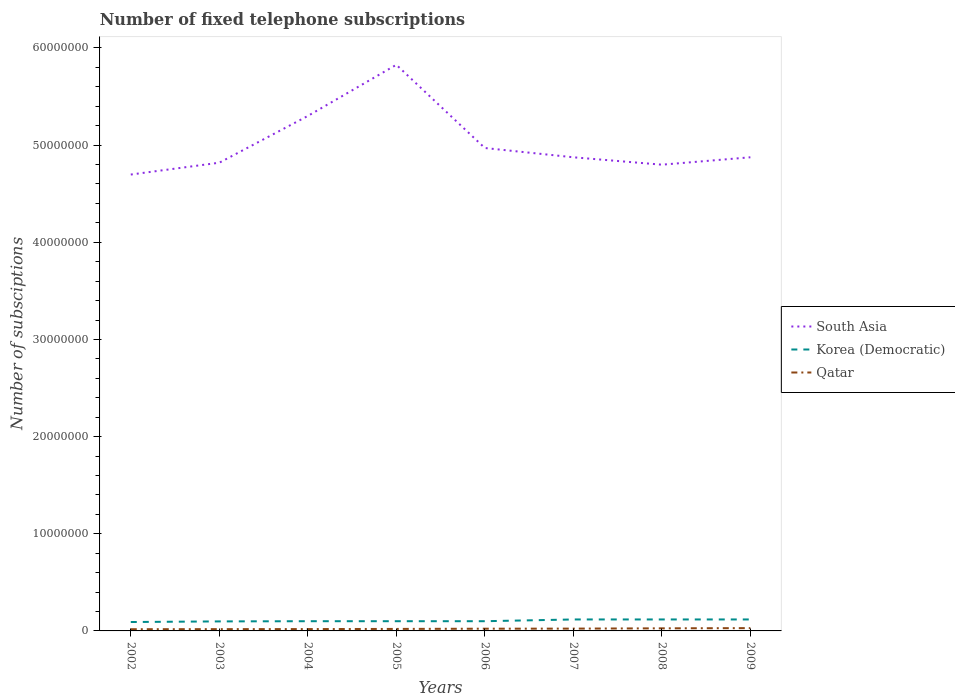Is the number of lines equal to the number of legend labels?
Offer a very short reply. Yes. Across all years, what is the maximum number of fixed telephone subscriptions in Qatar?
Ensure brevity in your answer.  1.77e+05. In which year was the number of fixed telephone subscriptions in South Asia maximum?
Give a very brief answer. 2002. What is the total number of fixed telephone subscriptions in Korea (Democratic) in the graph?
Offer a terse response. -1.80e+05. What is the difference between the highest and the second highest number of fixed telephone subscriptions in Qatar?
Make the answer very short. 1.11e+05. Is the number of fixed telephone subscriptions in South Asia strictly greater than the number of fixed telephone subscriptions in Korea (Democratic) over the years?
Your answer should be compact. No. Where does the legend appear in the graph?
Your answer should be compact. Center right. How many legend labels are there?
Make the answer very short. 3. What is the title of the graph?
Give a very brief answer. Number of fixed telephone subscriptions. What is the label or title of the X-axis?
Make the answer very short. Years. What is the label or title of the Y-axis?
Your answer should be very brief. Number of subsciptions. What is the Number of subsciptions of South Asia in 2002?
Offer a very short reply. 4.70e+07. What is the Number of subsciptions in Korea (Democratic) in 2002?
Provide a succinct answer. 9.16e+05. What is the Number of subsciptions of Qatar in 2002?
Your answer should be compact. 1.77e+05. What is the Number of subsciptions of South Asia in 2003?
Your response must be concise. 4.82e+07. What is the Number of subsciptions in Korea (Democratic) in 2003?
Keep it short and to the point. 9.80e+05. What is the Number of subsciptions in Qatar in 2003?
Provide a succinct answer. 1.85e+05. What is the Number of subsciptions in South Asia in 2004?
Provide a succinct answer. 5.30e+07. What is the Number of subsciptions of Korea (Democratic) in 2004?
Offer a very short reply. 1.00e+06. What is the Number of subsciptions in Qatar in 2004?
Provide a short and direct response. 1.91e+05. What is the Number of subsciptions of South Asia in 2005?
Keep it short and to the point. 5.83e+07. What is the Number of subsciptions of Qatar in 2005?
Keep it short and to the point. 2.05e+05. What is the Number of subsciptions of South Asia in 2006?
Make the answer very short. 4.97e+07. What is the Number of subsciptions in Qatar in 2006?
Provide a short and direct response. 2.28e+05. What is the Number of subsciptions in South Asia in 2007?
Provide a short and direct response. 4.87e+07. What is the Number of subsciptions in Korea (Democratic) in 2007?
Give a very brief answer. 1.18e+06. What is the Number of subsciptions of Qatar in 2007?
Provide a short and direct response. 2.37e+05. What is the Number of subsciptions of South Asia in 2008?
Your answer should be very brief. 4.80e+07. What is the Number of subsciptions of Korea (Democratic) in 2008?
Provide a short and direct response. 1.18e+06. What is the Number of subsciptions in Qatar in 2008?
Provide a succinct answer. 2.66e+05. What is the Number of subsciptions in South Asia in 2009?
Ensure brevity in your answer.  4.87e+07. What is the Number of subsciptions in Korea (Democratic) in 2009?
Make the answer very short. 1.18e+06. What is the Number of subsciptions of Qatar in 2009?
Your answer should be very brief. 2.88e+05. Across all years, what is the maximum Number of subsciptions of South Asia?
Your response must be concise. 5.83e+07. Across all years, what is the maximum Number of subsciptions of Korea (Democratic)?
Provide a succinct answer. 1.18e+06. Across all years, what is the maximum Number of subsciptions in Qatar?
Your answer should be compact. 2.88e+05. Across all years, what is the minimum Number of subsciptions in South Asia?
Keep it short and to the point. 4.70e+07. Across all years, what is the minimum Number of subsciptions of Korea (Democratic)?
Offer a terse response. 9.16e+05. Across all years, what is the minimum Number of subsciptions in Qatar?
Your answer should be compact. 1.77e+05. What is the total Number of subsciptions in South Asia in the graph?
Provide a succinct answer. 4.02e+08. What is the total Number of subsciptions of Korea (Democratic) in the graph?
Your answer should be very brief. 8.44e+06. What is the total Number of subsciptions in Qatar in the graph?
Provide a succinct answer. 1.78e+06. What is the difference between the Number of subsciptions in South Asia in 2002 and that in 2003?
Your answer should be compact. -1.22e+06. What is the difference between the Number of subsciptions in Korea (Democratic) in 2002 and that in 2003?
Your answer should be very brief. -6.40e+04. What is the difference between the Number of subsciptions in Qatar in 2002 and that in 2003?
Make the answer very short. -7989. What is the difference between the Number of subsciptions in South Asia in 2002 and that in 2004?
Provide a succinct answer. -6.03e+06. What is the difference between the Number of subsciptions in Korea (Democratic) in 2002 and that in 2004?
Your answer should be compact. -8.40e+04. What is the difference between the Number of subsciptions of Qatar in 2002 and that in 2004?
Provide a succinct answer. -1.44e+04. What is the difference between the Number of subsciptions of South Asia in 2002 and that in 2005?
Your response must be concise. -1.13e+07. What is the difference between the Number of subsciptions of Korea (Democratic) in 2002 and that in 2005?
Your answer should be compact. -8.40e+04. What is the difference between the Number of subsciptions in Qatar in 2002 and that in 2005?
Give a very brief answer. -2.89e+04. What is the difference between the Number of subsciptions in South Asia in 2002 and that in 2006?
Your answer should be very brief. -2.73e+06. What is the difference between the Number of subsciptions of Korea (Democratic) in 2002 and that in 2006?
Your response must be concise. -8.40e+04. What is the difference between the Number of subsciptions in Qatar in 2002 and that in 2006?
Make the answer very short. -5.18e+04. What is the difference between the Number of subsciptions in South Asia in 2002 and that in 2007?
Ensure brevity in your answer.  -1.78e+06. What is the difference between the Number of subsciptions of Korea (Democratic) in 2002 and that in 2007?
Your answer should be compact. -2.64e+05. What is the difference between the Number of subsciptions of Qatar in 2002 and that in 2007?
Provide a short and direct response. -6.08e+04. What is the difference between the Number of subsciptions of South Asia in 2002 and that in 2008?
Make the answer very short. -1.01e+06. What is the difference between the Number of subsciptions of Korea (Democratic) in 2002 and that in 2008?
Provide a succinct answer. -2.64e+05. What is the difference between the Number of subsciptions of Qatar in 2002 and that in 2008?
Offer a terse response. -8.93e+04. What is the difference between the Number of subsciptions in South Asia in 2002 and that in 2009?
Your response must be concise. -1.78e+06. What is the difference between the Number of subsciptions in Korea (Democratic) in 2002 and that in 2009?
Your answer should be compact. -2.64e+05. What is the difference between the Number of subsciptions in Qatar in 2002 and that in 2009?
Offer a very short reply. -1.11e+05. What is the difference between the Number of subsciptions of South Asia in 2003 and that in 2004?
Offer a terse response. -4.81e+06. What is the difference between the Number of subsciptions of Korea (Democratic) in 2003 and that in 2004?
Offer a very short reply. -2.00e+04. What is the difference between the Number of subsciptions of Qatar in 2003 and that in 2004?
Provide a short and direct response. -6368. What is the difference between the Number of subsciptions in South Asia in 2003 and that in 2005?
Ensure brevity in your answer.  -1.01e+07. What is the difference between the Number of subsciptions in Korea (Democratic) in 2003 and that in 2005?
Keep it short and to the point. -2.00e+04. What is the difference between the Number of subsciptions in Qatar in 2003 and that in 2005?
Ensure brevity in your answer.  -2.09e+04. What is the difference between the Number of subsciptions of South Asia in 2003 and that in 2006?
Provide a short and direct response. -1.51e+06. What is the difference between the Number of subsciptions in Qatar in 2003 and that in 2006?
Offer a terse response. -4.38e+04. What is the difference between the Number of subsciptions in South Asia in 2003 and that in 2007?
Your answer should be compact. -5.59e+05. What is the difference between the Number of subsciptions in Qatar in 2003 and that in 2007?
Keep it short and to the point. -5.29e+04. What is the difference between the Number of subsciptions in South Asia in 2003 and that in 2008?
Provide a short and direct response. 2.04e+05. What is the difference between the Number of subsciptions of Korea (Democratic) in 2003 and that in 2008?
Give a very brief answer. -2.00e+05. What is the difference between the Number of subsciptions of Qatar in 2003 and that in 2008?
Keep it short and to the point. -8.14e+04. What is the difference between the Number of subsciptions of South Asia in 2003 and that in 2009?
Your answer should be compact. -5.59e+05. What is the difference between the Number of subsciptions in Qatar in 2003 and that in 2009?
Give a very brief answer. -1.03e+05. What is the difference between the Number of subsciptions of South Asia in 2004 and that in 2005?
Your response must be concise. -5.27e+06. What is the difference between the Number of subsciptions in Qatar in 2004 and that in 2005?
Make the answer very short. -1.45e+04. What is the difference between the Number of subsciptions of South Asia in 2004 and that in 2006?
Provide a succinct answer. 3.30e+06. What is the difference between the Number of subsciptions of Qatar in 2004 and that in 2006?
Ensure brevity in your answer.  -3.75e+04. What is the difference between the Number of subsciptions of South Asia in 2004 and that in 2007?
Provide a succinct answer. 4.25e+06. What is the difference between the Number of subsciptions of Qatar in 2004 and that in 2007?
Make the answer very short. -4.65e+04. What is the difference between the Number of subsciptions of South Asia in 2004 and that in 2008?
Ensure brevity in your answer.  5.02e+06. What is the difference between the Number of subsciptions of Qatar in 2004 and that in 2008?
Ensure brevity in your answer.  -7.50e+04. What is the difference between the Number of subsciptions in South Asia in 2004 and that in 2009?
Your answer should be very brief. 4.25e+06. What is the difference between the Number of subsciptions in Qatar in 2004 and that in 2009?
Make the answer very short. -9.71e+04. What is the difference between the Number of subsciptions of South Asia in 2005 and that in 2006?
Offer a very short reply. 8.56e+06. What is the difference between the Number of subsciptions in Qatar in 2005 and that in 2006?
Your answer should be compact. -2.29e+04. What is the difference between the Number of subsciptions of South Asia in 2005 and that in 2007?
Provide a succinct answer. 9.52e+06. What is the difference between the Number of subsciptions in Korea (Democratic) in 2005 and that in 2007?
Provide a succinct answer. -1.80e+05. What is the difference between the Number of subsciptions of Qatar in 2005 and that in 2007?
Offer a terse response. -3.20e+04. What is the difference between the Number of subsciptions in South Asia in 2005 and that in 2008?
Offer a very short reply. 1.03e+07. What is the difference between the Number of subsciptions in Korea (Democratic) in 2005 and that in 2008?
Make the answer very short. -1.80e+05. What is the difference between the Number of subsciptions in Qatar in 2005 and that in 2008?
Offer a very short reply. -6.05e+04. What is the difference between the Number of subsciptions in South Asia in 2005 and that in 2009?
Keep it short and to the point. 9.52e+06. What is the difference between the Number of subsciptions of Qatar in 2005 and that in 2009?
Provide a short and direct response. -8.26e+04. What is the difference between the Number of subsciptions of South Asia in 2006 and that in 2007?
Ensure brevity in your answer.  9.54e+05. What is the difference between the Number of subsciptions of Korea (Democratic) in 2006 and that in 2007?
Your answer should be compact. -1.80e+05. What is the difference between the Number of subsciptions in Qatar in 2006 and that in 2007?
Give a very brief answer. -9041. What is the difference between the Number of subsciptions in South Asia in 2006 and that in 2008?
Keep it short and to the point. 1.72e+06. What is the difference between the Number of subsciptions in Korea (Democratic) in 2006 and that in 2008?
Your answer should be very brief. -1.80e+05. What is the difference between the Number of subsciptions of Qatar in 2006 and that in 2008?
Ensure brevity in your answer.  -3.75e+04. What is the difference between the Number of subsciptions in South Asia in 2006 and that in 2009?
Give a very brief answer. 9.54e+05. What is the difference between the Number of subsciptions of Korea (Democratic) in 2006 and that in 2009?
Your response must be concise. -1.80e+05. What is the difference between the Number of subsciptions in Qatar in 2006 and that in 2009?
Your answer should be compact. -5.96e+04. What is the difference between the Number of subsciptions of South Asia in 2007 and that in 2008?
Your answer should be compact. 7.62e+05. What is the difference between the Number of subsciptions in Qatar in 2007 and that in 2008?
Your answer should be compact. -2.85e+04. What is the difference between the Number of subsciptions of South Asia in 2007 and that in 2009?
Give a very brief answer. -456. What is the difference between the Number of subsciptions of Korea (Democratic) in 2007 and that in 2009?
Ensure brevity in your answer.  0. What is the difference between the Number of subsciptions in Qatar in 2007 and that in 2009?
Offer a very short reply. -5.06e+04. What is the difference between the Number of subsciptions in South Asia in 2008 and that in 2009?
Provide a succinct answer. -7.63e+05. What is the difference between the Number of subsciptions in Qatar in 2008 and that in 2009?
Make the answer very short. -2.21e+04. What is the difference between the Number of subsciptions in South Asia in 2002 and the Number of subsciptions in Korea (Democratic) in 2003?
Provide a succinct answer. 4.60e+07. What is the difference between the Number of subsciptions of South Asia in 2002 and the Number of subsciptions of Qatar in 2003?
Provide a short and direct response. 4.68e+07. What is the difference between the Number of subsciptions of Korea (Democratic) in 2002 and the Number of subsciptions of Qatar in 2003?
Offer a very short reply. 7.31e+05. What is the difference between the Number of subsciptions of South Asia in 2002 and the Number of subsciptions of Korea (Democratic) in 2004?
Offer a very short reply. 4.60e+07. What is the difference between the Number of subsciptions of South Asia in 2002 and the Number of subsciptions of Qatar in 2004?
Provide a succinct answer. 4.68e+07. What is the difference between the Number of subsciptions of Korea (Democratic) in 2002 and the Number of subsciptions of Qatar in 2004?
Your response must be concise. 7.25e+05. What is the difference between the Number of subsciptions in South Asia in 2002 and the Number of subsciptions in Korea (Democratic) in 2005?
Provide a short and direct response. 4.60e+07. What is the difference between the Number of subsciptions in South Asia in 2002 and the Number of subsciptions in Qatar in 2005?
Ensure brevity in your answer.  4.68e+07. What is the difference between the Number of subsciptions of Korea (Democratic) in 2002 and the Number of subsciptions of Qatar in 2005?
Offer a terse response. 7.11e+05. What is the difference between the Number of subsciptions of South Asia in 2002 and the Number of subsciptions of Korea (Democratic) in 2006?
Offer a very short reply. 4.60e+07. What is the difference between the Number of subsciptions of South Asia in 2002 and the Number of subsciptions of Qatar in 2006?
Make the answer very short. 4.67e+07. What is the difference between the Number of subsciptions in Korea (Democratic) in 2002 and the Number of subsciptions in Qatar in 2006?
Keep it short and to the point. 6.88e+05. What is the difference between the Number of subsciptions of South Asia in 2002 and the Number of subsciptions of Korea (Democratic) in 2007?
Your answer should be compact. 4.58e+07. What is the difference between the Number of subsciptions of South Asia in 2002 and the Number of subsciptions of Qatar in 2007?
Give a very brief answer. 4.67e+07. What is the difference between the Number of subsciptions in Korea (Democratic) in 2002 and the Number of subsciptions in Qatar in 2007?
Make the answer very short. 6.79e+05. What is the difference between the Number of subsciptions in South Asia in 2002 and the Number of subsciptions in Korea (Democratic) in 2008?
Keep it short and to the point. 4.58e+07. What is the difference between the Number of subsciptions in South Asia in 2002 and the Number of subsciptions in Qatar in 2008?
Offer a very short reply. 4.67e+07. What is the difference between the Number of subsciptions of Korea (Democratic) in 2002 and the Number of subsciptions of Qatar in 2008?
Give a very brief answer. 6.50e+05. What is the difference between the Number of subsciptions in South Asia in 2002 and the Number of subsciptions in Korea (Democratic) in 2009?
Ensure brevity in your answer.  4.58e+07. What is the difference between the Number of subsciptions of South Asia in 2002 and the Number of subsciptions of Qatar in 2009?
Give a very brief answer. 4.67e+07. What is the difference between the Number of subsciptions of Korea (Democratic) in 2002 and the Number of subsciptions of Qatar in 2009?
Provide a succinct answer. 6.28e+05. What is the difference between the Number of subsciptions of South Asia in 2003 and the Number of subsciptions of Korea (Democratic) in 2004?
Keep it short and to the point. 4.72e+07. What is the difference between the Number of subsciptions of South Asia in 2003 and the Number of subsciptions of Qatar in 2004?
Provide a succinct answer. 4.80e+07. What is the difference between the Number of subsciptions in Korea (Democratic) in 2003 and the Number of subsciptions in Qatar in 2004?
Provide a succinct answer. 7.89e+05. What is the difference between the Number of subsciptions of South Asia in 2003 and the Number of subsciptions of Korea (Democratic) in 2005?
Keep it short and to the point. 4.72e+07. What is the difference between the Number of subsciptions in South Asia in 2003 and the Number of subsciptions in Qatar in 2005?
Provide a short and direct response. 4.80e+07. What is the difference between the Number of subsciptions of Korea (Democratic) in 2003 and the Number of subsciptions of Qatar in 2005?
Your answer should be very brief. 7.75e+05. What is the difference between the Number of subsciptions of South Asia in 2003 and the Number of subsciptions of Korea (Democratic) in 2006?
Keep it short and to the point. 4.72e+07. What is the difference between the Number of subsciptions of South Asia in 2003 and the Number of subsciptions of Qatar in 2006?
Offer a very short reply. 4.80e+07. What is the difference between the Number of subsciptions of Korea (Democratic) in 2003 and the Number of subsciptions of Qatar in 2006?
Give a very brief answer. 7.52e+05. What is the difference between the Number of subsciptions in South Asia in 2003 and the Number of subsciptions in Korea (Democratic) in 2007?
Your answer should be compact. 4.70e+07. What is the difference between the Number of subsciptions of South Asia in 2003 and the Number of subsciptions of Qatar in 2007?
Ensure brevity in your answer.  4.80e+07. What is the difference between the Number of subsciptions of Korea (Democratic) in 2003 and the Number of subsciptions of Qatar in 2007?
Make the answer very short. 7.43e+05. What is the difference between the Number of subsciptions in South Asia in 2003 and the Number of subsciptions in Korea (Democratic) in 2008?
Give a very brief answer. 4.70e+07. What is the difference between the Number of subsciptions of South Asia in 2003 and the Number of subsciptions of Qatar in 2008?
Your answer should be very brief. 4.79e+07. What is the difference between the Number of subsciptions of Korea (Democratic) in 2003 and the Number of subsciptions of Qatar in 2008?
Provide a short and direct response. 7.14e+05. What is the difference between the Number of subsciptions in South Asia in 2003 and the Number of subsciptions in Korea (Democratic) in 2009?
Provide a short and direct response. 4.70e+07. What is the difference between the Number of subsciptions in South Asia in 2003 and the Number of subsciptions in Qatar in 2009?
Your answer should be very brief. 4.79e+07. What is the difference between the Number of subsciptions in Korea (Democratic) in 2003 and the Number of subsciptions in Qatar in 2009?
Ensure brevity in your answer.  6.92e+05. What is the difference between the Number of subsciptions in South Asia in 2004 and the Number of subsciptions in Korea (Democratic) in 2005?
Offer a very short reply. 5.20e+07. What is the difference between the Number of subsciptions of South Asia in 2004 and the Number of subsciptions of Qatar in 2005?
Your answer should be compact. 5.28e+07. What is the difference between the Number of subsciptions in Korea (Democratic) in 2004 and the Number of subsciptions in Qatar in 2005?
Offer a terse response. 7.95e+05. What is the difference between the Number of subsciptions of South Asia in 2004 and the Number of subsciptions of Korea (Democratic) in 2006?
Offer a very short reply. 5.20e+07. What is the difference between the Number of subsciptions in South Asia in 2004 and the Number of subsciptions in Qatar in 2006?
Provide a succinct answer. 5.28e+07. What is the difference between the Number of subsciptions of Korea (Democratic) in 2004 and the Number of subsciptions of Qatar in 2006?
Ensure brevity in your answer.  7.72e+05. What is the difference between the Number of subsciptions of South Asia in 2004 and the Number of subsciptions of Korea (Democratic) in 2007?
Ensure brevity in your answer.  5.18e+07. What is the difference between the Number of subsciptions in South Asia in 2004 and the Number of subsciptions in Qatar in 2007?
Offer a very short reply. 5.28e+07. What is the difference between the Number of subsciptions in Korea (Democratic) in 2004 and the Number of subsciptions in Qatar in 2007?
Offer a very short reply. 7.63e+05. What is the difference between the Number of subsciptions of South Asia in 2004 and the Number of subsciptions of Korea (Democratic) in 2008?
Provide a succinct answer. 5.18e+07. What is the difference between the Number of subsciptions of South Asia in 2004 and the Number of subsciptions of Qatar in 2008?
Ensure brevity in your answer.  5.27e+07. What is the difference between the Number of subsciptions of Korea (Democratic) in 2004 and the Number of subsciptions of Qatar in 2008?
Make the answer very short. 7.34e+05. What is the difference between the Number of subsciptions in South Asia in 2004 and the Number of subsciptions in Korea (Democratic) in 2009?
Provide a succinct answer. 5.18e+07. What is the difference between the Number of subsciptions in South Asia in 2004 and the Number of subsciptions in Qatar in 2009?
Your response must be concise. 5.27e+07. What is the difference between the Number of subsciptions of Korea (Democratic) in 2004 and the Number of subsciptions of Qatar in 2009?
Make the answer very short. 7.12e+05. What is the difference between the Number of subsciptions in South Asia in 2005 and the Number of subsciptions in Korea (Democratic) in 2006?
Offer a very short reply. 5.73e+07. What is the difference between the Number of subsciptions of South Asia in 2005 and the Number of subsciptions of Qatar in 2006?
Your response must be concise. 5.80e+07. What is the difference between the Number of subsciptions of Korea (Democratic) in 2005 and the Number of subsciptions of Qatar in 2006?
Keep it short and to the point. 7.72e+05. What is the difference between the Number of subsciptions of South Asia in 2005 and the Number of subsciptions of Korea (Democratic) in 2007?
Your answer should be compact. 5.71e+07. What is the difference between the Number of subsciptions in South Asia in 2005 and the Number of subsciptions in Qatar in 2007?
Keep it short and to the point. 5.80e+07. What is the difference between the Number of subsciptions of Korea (Democratic) in 2005 and the Number of subsciptions of Qatar in 2007?
Your answer should be compact. 7.63e+05. What is the difference between the Number of subsciptions in South Asia in 2005 and the Number of subsciptions in Korea (Democratic) in 2008?
Ensure brevity in your answer.  5.71e+07. What is the difference between the Number of subsciptions of South Asia in 2005 and the Number of subsciptions of Qatar in 2008?
Give a very brief answer. 5.80e+07. What is the difference between the Number of subsciptions of Korea (Democratic) in 2005 and the Number of subsciptions of Qatar in 2008?
Provide a succinct answer. 7.34e+05. What is the difference between the Number of subsciptions in South Asia in 2005 and the Number of subsciptions in Korea (Democratic) in 2009?
Keep it short and to the point. 5.71e+07. What is the difference between the Number of subsciptions of South Asia in 2005 and the Number of subsciptions of Qatar in 2009?
Your answer should be very brief. 5.80e+07. What is the difference between the Number of subsciptions in Korea (Democratic) in 2005 and the Number of subsciptions in Qatar in 2009?
Give a very brief answer. 7.12e+05. What is the difference between the Number of subsciptions of South Asia in 2006 and the Number of subsciptions of Korea (Democratic) in 2007?
Your answer should be compact. 4.85e+07. What is the difference between the Number of subsciptions of South Asia in 2006 and the Number of subsciptions of Qatar in 2007?
Keep it short and to the point. 4.95e+07. What is the difference between the Number of subsciptions of Korea (Democratic) in 2006 and the Number of subsciptions of Qatar in 2007?
Give a very brief answer. 7.63e+05. What is the difference between the Number of subsciptions of South Asia in 2006 and the Number of subsciptions of Korea (Democratic) in 2008?
Make the answer very short. 4.85e+07. What is the difference between the Number of subsciptions of South Asia in 2006 and the Number of subsciptions of Qatar in 2008?
Give a very brief answer. 4.94e+07. What is the difference between the Number of subsciptions in Korea (Democratic) in 2006 and the Number of subsciptions in Qatar in 2008?
Keep it short and to the point. 7.34e+05. What is the difference between the Number of subsciptions in South Asia in 2006 and the Number of subsciptions in Korea (Democratic) in 2009?
Give a very brief answer. 4.85e+07. What is the difference between the Number of subsciptions in South Asia in 2006 and the Number of subsciptions in Qatar in 2009?
Your response must be concise. 4.94e+07. What is the difference between the Number of subsciptions in Korea (Democratic) in 2006 and the Number of subsciptions in Qatar in 2009?
Your response must be concise. 7.12e+05. What is the difference between the Number of subsciptions in South Asia in 2007 and the Number of subsciptions in Korea (Democratic) in 2008?
Your answer should be compact. 4.76e+07. What is the difference between the Number of subsciptions of South Asia in 2007 and the Number of subsciptions of Qatar in 2008?
Your answer should be very brief. 4.85e+07. What is the difference between the Number of subsciptions of Korea (Democratic) in 2007 and the Number of subsciptions of Qatar in 2008?
Make the answer very short. 9.14e+05. What is the difference between the Number of subsciptions in South Asia in 2007 and the Number of subsciptions in Korea (Democratic) in 2009?
Offer a terse response. 4.76e+07. What is the difference between the Number of subsciptions of South Asia in 2007 and the Number of subsciptions of Qatar in 2009?
Ensure brevity in your answer.  4.85e+07. What is the difference between the Number of subsciptions of Korea (Democratic) in 2007 and the Number of subsciptions of Qatar in 2009?
Provide a succinct answer. 8.92e+05. What is the difference between the Number of subsciptions in South Asia in 2008 and the Number of subsciptions in Korea (Democratic) in 2009?
Give a very brief answer. 4.68e+07. What is the difference between the Number of subsciptions in South Asia in 2008 and the Number of subsciptions in Qatar in 2009?
Your answer should be compact. 4.77e+07. What is the difference between the Number of subsciptions of Korea (Democratic) in 2008 and the Number of subsciptions of Qatar in 2009?
Your answer should be very brief. 8.92e+05. What is the average Number of subsciptions in South Asia per year?
Provide a short and direct response. 5.02e+07. What is the average Number of subsciptions of Korea (Democratic) per year?
Your answer should be compact. 1.05e+06. What is the average Number of subsciptions of Qatar per year?
Make the answer very short. 2.22e+05. In the year 2002, what is the difference between the Number of subsciptions of South Asia and Number of subsciptions of Korea (Democratic)?
Your response must be concise. 4.61e+07. In the year 2002, what is the difference between the Number of subsciptions of South Asia and Number of subsciptions of Qatar?
Provide a succinct answer. 4.68e+07. In the year 2002, what is the difference between the Number of subsciptions of Korea (Democratic) and Number of subsciptions of Qatar?
Your response must be concise. 7.39e+05. In the year 2003, what is the difference between the Number of subsciptions of South Asia and Number of subsciptions of Korea (Democratic)?
Give a very brief answer. 4.72e+07. In the year 2003, what is the difference between the Number of subsciptions in South Asia and Number of subsciptions in Qatar?
Keep it short and to the point. 4.80e+07. In the year 2003, what is the difference between the Number of subsciptions of Korea (Democratic) and Number of subsciptions of Qatar?
Ensure brevity in your answer.  7.95e+05. In the year 2004, what is the difference between the Number of subsciptions in South Asia and Number of subsciptions in Korea (Democratic)?
Make the answer very short. 5.20e+07. In the year 2004, what is the difference between the Number of subsciptions in South Asia and Number of subsciptions in Qatar?
Make the answer very short. 5.28e+07. In the year 2004, what is the difference between the Number of subsciptions in Korea (Democratic) and Number of subsciptions in Qatar?
Ensure brevity in your answer.  8.09e+05. In the year 2005, what is the difference between the Number of subsciptions in South Asia and Number of subsciptions in Korea (Democratic)?
Your response must be concise. 5.73e+07. In the year 2005, what is the difference between the Number of subsciptions in South Asia and Number of subsciptions in Qatar?
Ensure brevity in your answer.  5.81e+07. In the year 2005, what is the difference between the Number of subsciptions in Korea (Democratic) and Number of subsciptions in Qatar?
Provide a succinct answer. 7.95e+05. In the year 2006, what is the difference between the Number of subsciptions in South Asia and Number of subsciptions in Korea (Democratic)?
Make the answer very short. 4.87e+07. In the year 2006, what is the difference between the Number of subsciptions in South Asia and Number of subsciptions in Qatar?
Ensure brevity in your answer.  4.95e+07. In the year 2006, what is the difference between the Number of subsciptions in Korea (Democratic) and Number of subsciptions in Qatar?
Ensure brevity in your answer.  7.72e+05. In the year 2007, what is the difference between the Number of subsciptions in South Asia and Number of subsciptions in Korea (Democratic)?
Your answer should be compact. 4.76e+07. In the year 2007, what is the difference between the Number of subsciptions in South Asia and Number of subsciptions in Qatar?
Ensure brevity in your answer.  4.85e+07. In the year 2007, what is the difference between the Number of subsciptions in Korea (Democratic) and Number of subsciptions in Qatar?
Provide a short and direct response. 9.43e+05. In the year 2008, what is the difference between the Number of subsciptions of South Asia and Number of subsciptions of Korea (Democratic)?
Give a very brief answer. 4.68e+07. In the year 2008, what is the difference between the Number of subsciptions in South Asia and Number of subsciptions in Qatar?
Offer a very short reply. 4.77e+07. In the year 2008, what is the difference between the Number of subsciptions of Korea (Democratic) and Number of subsciptions of Qatar?
Ensure brevity in your answer.  9.14e+05. In the year 2009, what is the difference between the Number of subsciptions of South Asia and Number of subsciptions of Korea (Democratic)?
Offer a very short reply. 4.76e+07. In the year 2009, what is the difference between the Number of subsciptions of South Asia and Number of subsciptions of Qatar?
Offer a terse response. 4.85e+07. In the year 2009, what is the difference between the Number of subsciptions of Korea (Democratic) and Number of subsciptions of Qatar?
Your answer should be very brief. 8.92e+05. What is the ratio of the Number of subsciptions of South Asia in 2002 to that in 2003?
Your response must be concise. 0.97. What is the ratio of the Number of subsciptions in Korea (Democratic) in 2002 to that in 2003?
Make the answer very short. 0.93. What is the ratio of the Number of subsciptions in Qatar in 2002 to that in 2003?
Give a very brief answer. 0.96. What is the ratio of the Number of subsciptions of South Asia in 2002 to that in 2004?
Offer a terse response. 0.89. What is the ratio of the Number of subsciptions of Korea (Democratic) in 2002 to that in 2004?
Offer a very short reply. 0.92. What is the ratio of the Number of subsciptions in Qatar in 2002 to that in 2004?
Offer a terse response. 0.92. What is the ratio of the Number of subsciptions of South Asia in 2002 to that in 2005?
Make the answer very short. 0.81. What is the ratio of the Number of subsciptions of Korea (Democratic) in 2002 to that in 2005?
Your answer should be very brief. 0.92. What is the ratio of the Number of subsciptions in Qatar in 2002 to that in 2005?
Keep it short and to the point. 0.86. What is the ratio of the Number of subsciptions of South Asia in 2002 to that in 2006?
Your answer should be compact. 0.95. What is the ratio of the Number of subsciptions in Korea (Democratic) in 2002 to that in 2006?
Your answer should be compact. 0.92. What is the ratio of the Number of subsciptions of Qatar in 2002 to that in 2006?
Ensure brevity in your answer.  0.77. What is the ratio of the Number of subsciptions in South Asia in 2002 to that in 2007?
Ensure brevity in your answer.  0.96. What is the ratio of the Number of subsciptions in Korea (Democratic) in 2002 to that in 2007?
Provide a succinct answer. 0.78. What is the ratio of the Number of subsciptions of Qatar in 2002 to that in 2007?
Keep it short and to the point. 0.74. What is the ratio of the Number of subsciptions of South Asia in 2002 to that in 2008?
Your answer should be compact. 0.98. What is the ratio of the Number of subsciptions in Korea (Democratic) in 2002 to that in 2008?
Your answer should be very brief. 0.78. What is the ratio of the Number of subsciptions of Qatar in 2002 to that in 2008?
Offer a terse response. 0.66. What is the ratio of the Number of subsciptions of South Asia in 2002 to that in 2009?
Your response must be concise. 0.96. What is the ratio of the Number of subsciptions of Korea (Democratic) in 2002 to that in 2009?
Provide a short and direct response. 0.78. What is the ratio of the Number of subsciptions of Qatar in 2002 to that in 2009?
Your answer should be compact. 0.61. What is the ratio of the Number of subsciptions of South Asia in 2003 to that in 2004?
Offer a terse response. 0.91. What is the ratio of the Number of subsciptions of Qatar in 2003 to that in 2004?
Give a very brief answer. 0.97. What is the ratio of the Number of subsciptions of South Asia in 2003 to that in 2005?
Give a very brief answer. 0.83. What is the ratio of the Number of subsciptions of Korea (Democratic) in 2003 to that in 2005?
Give a very brief answer. 0.98. What is the ratio of the Number of subsciptions in Qatar in 2003 to that in 2005?
Ensure brevity in your answer.  0.9. What is the ratio of the Number of subsciptions in South Asia in 2003 to that in 2006?
Make the answer very short. 0.97. What is the ratio of the Number of subsciptions of Korea (Democratic) in 2003 to that in 2006?
Your response must be concise. 0.98. What is the ratio of the Number of subsciptions of Qatar in 2003 to that in 2006?
Your response must be concise. 0.81. What is the ratio of the Number of subsciptions in Korea (Democratic) in 2003 to that in 2007?
Offer a terse response. 0.83. What is the ratio of the Number of subsciptions in Qatar in 2003 to that in 2007?
Provide a short and direct response. 0.78. What is the ratio of the Number of subsciptions of Korea (Democratic) in 2003 to that in 2008?
Your response must be concise. 0.83. What is the ratio of the Number of subsciptions in Qatar in 2003 to that in 2008?
Make the answer very short. 0.69. What is the ratio of the Number of subsciptions in South Asia in 2003 to that in 2009?
Keep it short and to the point. 0.99. What is the ratio of the Number of subsciptions of Korea (Democratic) in 2003 to that in 2009?
Make the answer very short. 0.83. What is the ratio of the Number of subsciptions in Qatar in 2003 to that in 2009?
Offer a terse response. 0.64. What is the ratio of the Number of subsciptions in South Asia in 2004 to that in 2005?
Provide a short and direct response. 0.91. What is the ratio of the Number of subsciptions of Korea (Democratic) in 2004 to that in 2005?
Offer a terse response. 1. What is the ratio of the Number of subsciptions in Qatar in 2004 to that in 2005?
Your answer should be compact. 0.93. What is the ratio of the Number of subsciptions of South Asia in 2004 to that in 2006?
Offer a very short reply. 1.07. What is the ratio of the Number of subsciptions of Qatar in 2004 to that in 2006?
Make the answer very short. 0.84. What is the ratio of the Number of subsciptions of South Asia in 2004 to that in 2007?
Keep it short and to the point. 1.09. What is the ratio of the Number of subsciptions of Korea (Democratic) in 2004 to that in 2007?
Your response must be concise. 0.85. What is the ratio of the Number of subsciptions of Qatar in 2004 to that in 2007?
Provide a succinct answer. 0.8. What is the ratio of the Number of subsciptions in South Asia in 2004 to that in 2008?
Offer a terse response. 1.1. What is the ratio of the Number of subsciptions in Korea (Democratic) in 2004 to that in 2008?
Offer a terse response. 0.85. What is the ratio of the Number of subsciptions in Qatar in 2004 to that in 2008?
Make the answer very short. 0.72. What is the ratio of the Number of subsciptions of South Asia in 2004 to that in 2009?
Ensure brevity in your answer.  1.09. What is the ratio of the Number of subsciptions of Korea (Democratic) in 2004 to that in 2009?
Make the answer very short. 0.85. What is the ratio of the Number of subsciptions of Qatar in 2004 to that in 2009?
Provide a succinct answer. 0.66. What is the ratio of the Number of subsciptions in South Asia in 2005 to that in 2006?
Give a very brief answer. 1.17. What is the ratio of the Number of subsciptions in Qatar in 2005 to that in 2006?
Your answer should be very brief. 0.9. What is the ratio of the Number of subsciptions in South Asia in 2005 to that in 2007?
Provide a short and direct response. 1.2. What is the ratio of the Number of subsciptions of Korea (Democratic) in 2005 to that in 2007?
Ensure brevity in your answer.  0.85. What is the ratio of the Number of subsciptions of Qatar in 2005 to that in 2007?
Keep it short and to the point. 0.87. What is the ratio of the Number of subsciptions of South Asia in 2005 to that in 2008?
Offer a very short reply. 1.21. What is the ratio of the Number of subsciptions in Korea (Democratic) in 2005 to that in 2008?
Provide a short and direct response. 0.85. What is the ratio of the Number of subsciptions of Qatar in 2005 to that in 2008?
Offer a terse response. 0.77. What is the ratio of the Number of subsciptions of South Asia in 2005 to that in 2009?
Ensure brevity in your answer.  1.2. What is the ratio of the Number of subsciptions in Korea (Democratic) in 2005 to that in 2009?
Your answer should be compact. 0.85. What is the ratio of the Number of subsciptions of Qatar in 2005 to that in 2009?
Your response must be concise. 0.71. What is the ratio of the Number of subsciptions of South Asia in 2006 to that in 2007?
Offer a very short reply. 1.02. What is the ratio of the Number of subsciptions of Korea (Democratic) in 2006 to that in 2007?
Ensure brevity in your answer.  0.85. What is the ratio of the Number of subsciptions of Qatar in 2006 to that in 2007?
Make the answer very short. 0.96. What is the ratio of the Number of subsciptions in South Asia in 2006 to that in 2008?
Give a very brief answer. 1.04. What is the ratio of the Number of subsciptions of Korea (Democratic) in 2006 to that in 2008?
Offer a terse response. 0.85. What is the ratio of the Number of subsciptions in Qatar in 2006 to that in 2008?
Your response must be concise. 0.86. What is the ratio of the Number of subsciptions of South Asia in 2006 to that in 2009?
Offer a very short reply. 1.02. What is the ratio of the Number of subsciptions in Korea (Democratic) in 2006 to that in 2009?
Give a very brief answer. 0.85. What is the ratio of the Number of subsciptions in Qatar in 2006 to that in 2009?
Offer a terse response. 0.79. What is the ratio of the Number of subsciptions in South Asia in 2007 to that in 2008?
Your response must be concise. 1.02. What is the ratio of the Number of subsciptions in Qatar in 2007 to that in 2008?
Make the answer very short. 0.89. What is the ratio of the Number of subsciptions in South Asia in 2007 to that in 2009?
Make the answer very short. 1. What is the ratio of the Number of subsciptions in Korea (Democratic) in 2007 to that in 2009?
Your answer should be very brief. 1. What is the ratio of the Number of subsciptions of Qatar in 2007 to that in 2009?
Provide a succinct answer. 0.82. What is the ratio of the Number of subsciptions in South Asia in 2008 to that in 2009?
Provide a succinct answer. 0.98. What is the ratio of the Number of subsciptions of Korea (Democratic) in 2008 to that in 2009?
Ensure brevity in your answer.  1. What is the ratio of the Number of subsciptions in Qatar in 2008 to that in 2009?
Ensure brevity in your answer.  0.92. What is the difference between the highest and the second highest Number of subsciptions in South Asia?
Keep it short and to the point. 5.27e+06. What is the difference between the highest and the second highest Number of subsciptions in Korea (Democratic)?
Provide a succinct answer. 0. What is the difference between the highest and the second highest Number of subsciptions of Qatar?
Your answer should be very brief. 2.21e+04. What is the difference between the highest and the lowest Number of subsciptions of South Asia?
Keep it short and to the point. 1.13e+07. What is the difference between the highest and the lowest Number of subsciptions of Korea (Democratic)?
Your answer should be compact. 2.64e+05. What is the difference between the highest and the lowest Number of subsciptions in Qatar?
Make the answer very short. 1.11e+05. 